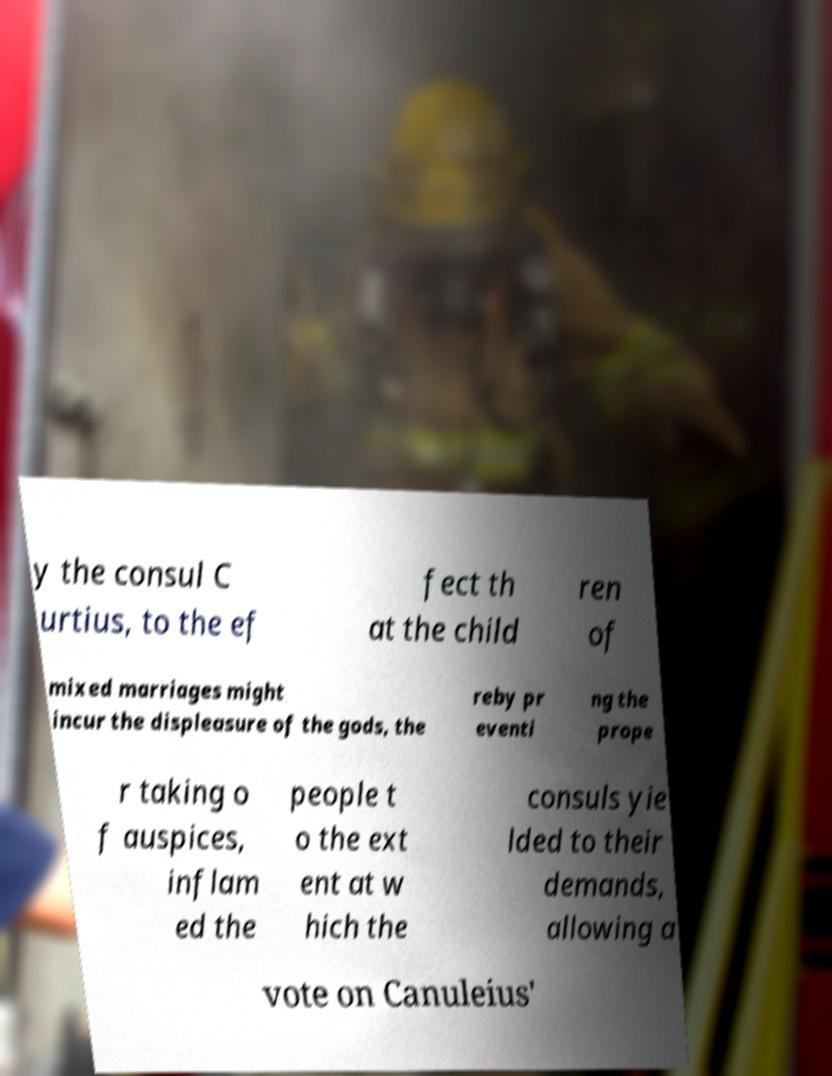Could you assist in decoding the text presented in this image and type it out clearly? y the consul C urtius, to the ef fect th at the child ren of mixed marriages might incur the displeasure of the gods, the reby pr eventi ng the prope r taking o f auspices, inflam ed the people t o the ext ent at w hich the consuls yie lded to their demands, allowing a vote on Canuleius' 